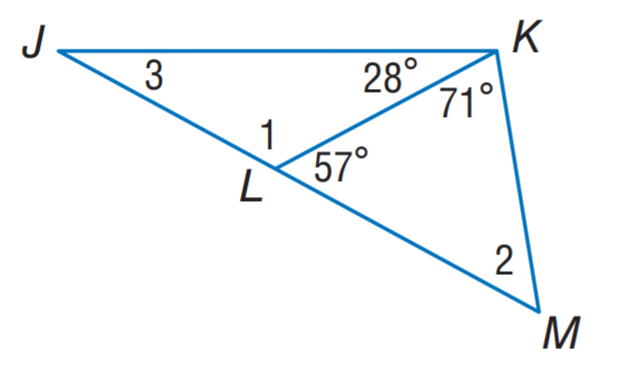Question: Find m \angle 2.
Choices:
A. 29
B. 52
C. 57
D. 123
Answer with the letter. Answer: B Question: Find m \angle 1.
Choices:
A. 52
B. 123
C. 128
D. 151
Answer with the letter. Answer: B Question: Find m \angle 3.
Choices:
A. 28
B. 29
C. 52
D. 123
Answer with the letter. Answer: B 